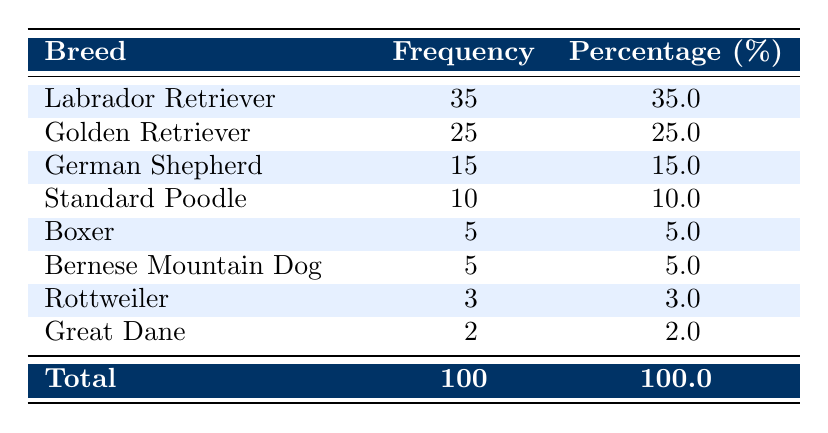What breed has the highest frequency as a mobility assistance animal? From the table, we can see that the "Labrador Retriever" has the highest frequency listed at 35.
Answer: Labrador Retriever How many breeds have a frequency of 5 or fewer? We can look at the frequencies listed: "Boxer" has 5, "Bernese Mountain Dog" has 5, "Rottweiler" has 3, and "Great Dane" has 2. This totals to 4 breeds with a frequency of 5 or fewer.
Answer: 4 What is the total frequency of all breeds combined? By adding the frequencies together: 35 + 25 + 15 + 10 + 5 + 5 + 3 + 2 = 100. So, the total frequency of all breeds is 100.
Answer: 100 What percentage of mobility assistance animals are German Shepherds? The table states that the frequency of German Shepherds is 15, and the total frequency is 100. The percentage is calculated as (15/100)*100 = 15.0%.
Answer: 15.0% Are there more Golden Retrievers or German Shepherds trained as mobility assistance animals? According to the table, Golden Retrievers have a frequency of 25, while German Shepherds have a frequency of 15. Since 25 is greater than 15, there are more Golden Retrievers compared to German Shepherds.
Answer: Yes If you combine the frequencies of Rottweilers and Great Danes, what is their total frequency? The frequency for Rottweilers is 3 and for Great Danes is 2. Adding these gives us 3 + 2 = 5.
Answer: 5 Which breed has a frequency closest to the average frequency of all listed breeds? To find the average, sum the frequencies (100) and divide by the number of breeds (8): 100/8 = 12.5. The breed with the closest frequency is "German Shepherd" at 15.
Answer: German Shepherd Which breed represents more than 30% of the total frequency? Looking at the table, the "Labrador Retriever" has a frequency of 35, which represents (35/100)*100 = 35%. This is more than 30%.
Answer: Yes 